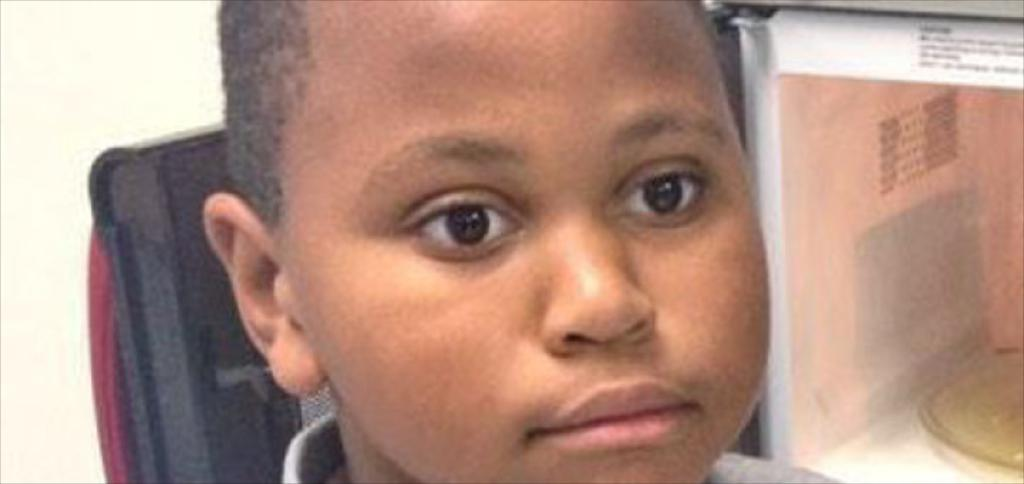Who is in the picture? There is a boy in the picture. What appliance can be seen in the image? There is a microwave oven in the picture. On which side of the image is the microwave oven located? The microwave oven is on the right side of the image. What is the status of the microwave oven's door? The door of the microwave oven is opened. What type of fiction is the boy reading in the image? There is no book or any form of fiction present in the image. 